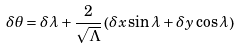<formula> <loc_0><loc_0><loc_500><loc_500>\delta \theta & = \delta \lambda + \frac { 2 } { \sqrt { \Lambda } } \left ( \delta x \sin { \lambda } + \delta y \cos { \lambda } \right )</formula> 